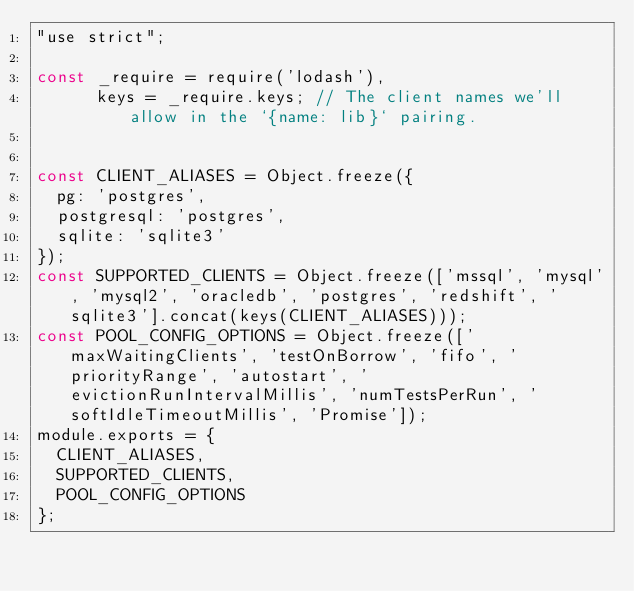<code> <loc_0><loc_0><loc_500><loc_500><_JavaScript_>"use strict";

const _require = require('lodash'),
      keys = _require.keys; // The client names we'll allow in the `{name: lib}` pairing.


const CLIENT_ALIASES = Object.freeze({
  pg: 'postgres',
  postgresql: 'postgres',
  sqlite: 'sqlite3'
});
const SUPPORTED_CLIENTS = Object.freeze(['mssql', 'mysql', 'mysql2', 'oracledb', 'postgres', 'redshift', 'sqlite3'].concat(keys(CLIENT_ALIASES)));
const POOL_CONFIG_OPTIONS = Object.freeze(['maxWaitingClients', 'testOnBorrow', 'fifo', 'priorityRange', 'autostart', 'evictionRunIntervalMillis', 'numTestsPerRun', 'softIdleTimeoutMillis', 'Promise']);
module.exports = {
  CLIENT_ALIASES,
  SUPPORTED_CLIENTS,
  POOL_CONFIG_OPTIONS
};</code> 